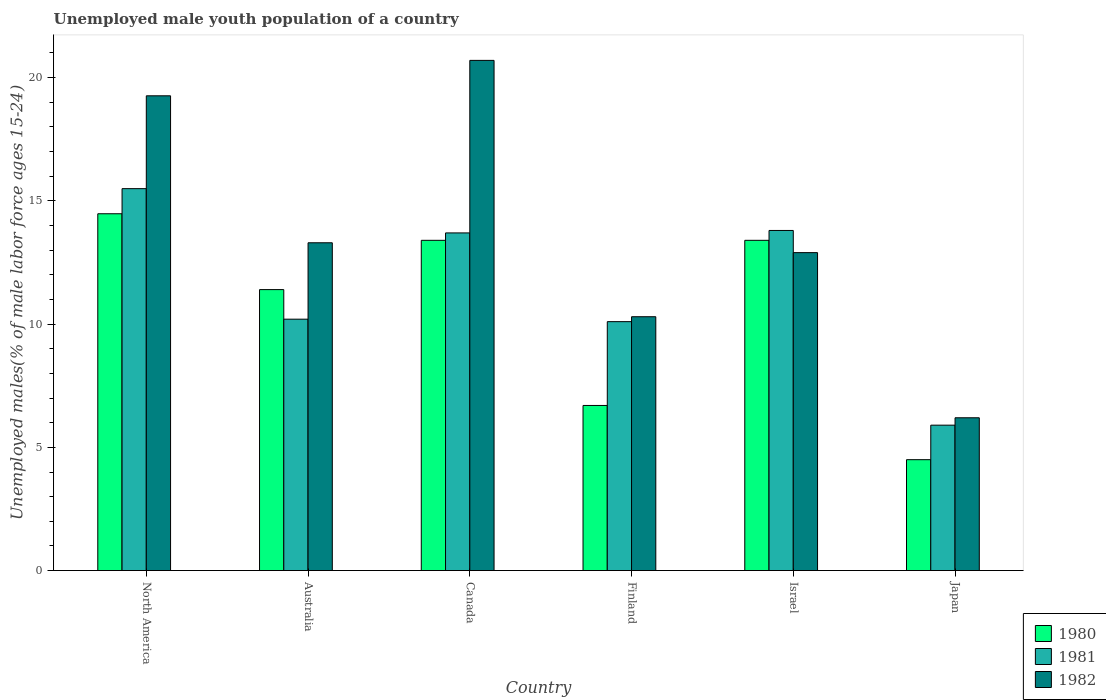How many groups of bars are there?
Your answer should be very brief. 6. What is the label of the 3rd group of bars from the left?
Keep it short and to the point. Canada. In how many cases, is the number of bars for a given country not equal to the number of legend labels?
Make the answer very short. 0. What is the percentage of unemployed male youth population in 1980 in Canada?
Your answer should be compact. 13.4. Across all countries, what is the maximum percentage of unemployed male youth population in 1982?
Provide a succinct answer. 20.7. Across all countries, what is the minimum percentage of unemployed male youth population in 1980?
Offer a very short reply. 4.5. In which country was the percentage of unemployed male youth population in 1982 maximum?
Give a very brief answer. Canada. What is the total percentage of unemployed male youth population in 1981 in the graph?
Give a very brief answer. 69.2. What is the difference between the percentage of unemployed male youth population in 1981 in Australia and that in Canada?
Your response must be concise. -3.5. What is the difference between the percentage of unemployed male youth population in 1982 in Canada and the percentage of unemployed male youth population in 1980 in Australia?
Your answer should be very brief. 9.3. What is the average percentage of unemployed male youth population in 1980 per country?
Your answer should be compact. 10.65. What is the difference between the percentage of unemployed male youth population of/in 1981 and percentage of unemployed male youth population of/in 1982 in Israel?
Your answer should be compact. 0.9. What is the ratio of the percentage of unemployed male youth population in 1982 in Japan to that in North America?
Your answer should be very brief. 0.32. Is the percentage of unemployed male youth population in 1981 in Finland less than that in Japan?
Your answer should be compact. No. What is the difference between the highest and the second highest percentage of unemployed male youth population in 1981?
Keep it short and to the point. -0.1. What is the difference between the highest and the lowest percentage of unemployed male youth population in 1981?
Keep it short and to the point. 9.6. Is the sum of the percentage of unemployed male youth population in 1981 in Australia and Israel greater than the maximum percentage of unemployed male youth population in 1980 across all countries?
Keep it short and to the point. Yes. What does the 3rd bar from the left in Finland represents?
Ensure brevity in your answer.  1982. What does the 2nd bar from the right in Japan represents?
Ensure brevity in your answer.  1981. Is it the case that in every country, the sum of the percentage of unemployed male youth population in 1981 and percentage of unemployed male youth population in 1980 is greater than the percentage of unemployed male youth population in 1982?
Make the answer very short. Yes. How many bars are there?
Provide a succinct answer. 18. Are all the bars in the graph horizontal?
Provide a short and direct response. No. What is the difference between two consecutive major ticks on the Y-axis?
Your answer should be compact. 5. Are the values on the major ticks of Y-axis written in scientific E-notation?
Offer a very short reply. No. Does the graph contain grids?
Ensure brevity in your answer.  No. What is the title of the graph?
Provide a succinct answer. Unemployed male youth population of a country. What is the label or title of the X-axis?
Your response must be concise. Country. What is the label or title of the Y-axis?
Give a very brief answer. Unemployed males(% of male labor force ages 15-24). What is the Unemployed males(% of male labor force ages 15-24) of 1980 in North America?
Offer a very short reply. 14.48. What is the Unemployed males(% of male labor force ages 15-24) in 1981 in North America?
Make the answer very short. 15.5. What is the Unemployed males(% of male labor force ages 15-24) in 1982 in North America?
Ensure brevity in your answer.  19.26. What is the Unemployed males(% of male labor force ages 15-24) of 1980 in Australia?
Offer a terse response. 11.4. What is the Unemployed males(% of male labor force ages 15-24) of 1981 in Australia?
Make the answer very short. 10.2. What is the Unemployed males(% of male labor force ages 15-24) of 1982 in Australia?
Make the answer very short. 13.3. What is the Unemployed males(% of male labor force ages 15-24) in 1980 in Canada?
Your answer should be compact. 13.4. What is the Unemployed males(% of male labor force ages 15-24) in 1981 in Canada?
Your response must be concise. 13.7. What is the Unemployed males(% of male labor force ages 15-24) in 1982 in Canada?
Your answer should be compact. 20.7. What is the Unemployed males(% of male labor force ages 15-24) in 1980 in Finland?
Ensure brevity in your answer.  6.7. What is the Unemployed males(% of male labor force ages 15-24) in 1981 in Finland?
Offer a terse response. 10.1. What is the Unemployed males(% of male labor force ages 15-24) in 1982 in Finland?
Provide a short and direct response. 10.3. What is the Unemployed males(% of male labor force ages 15-24) of 1980 in Israel?
Offer a very short reply. 13.4. What is the Unemployed males(% of male labor force ages 15-24) in 1981 in Israel?
Provide a short and direct response. 13.8. What is the Unemployed males(% of male labor force ages 15-24) in 1982 in Israel?
Provide a short and direct response. 12.9. What is the Unemployed males(% of male labor force ages 15-24) of 1981 in Japan?
Give a very brief answer. 5.9. What is the Unemployed males(% of male labor force ages 15-24) of 1982 in Japan?
Offer a very short reply. 6.2. Across all countries, what is the maximum Unemployed males(% of male labor force ages 15-24) of 1980?
Provide a short and direct response. 14.48. Across all countries, what is the maximum Unemployed males(% of male labor force ages 15-24) of 1981?
Keep it short and to the point. 15.5. Across all countries, what is the maximum Unemployed males(% of male labor force ages 15-24) of 1982?
Provide a short and direct response. 20.7. Across all countries, what is the minimum Unemployed males(% of male labor force ages 15-24) of 1980?
Your answer should be very brief. 4.5. Across all countries, what is the minimum Unemployed males(% of male labor force ages 15-24) of 1981?
Give a very brief answer. 5.9. Across all countries, what is the minimum Unemployed males(% of male labor force ages 15-24) in 1982?
Your answer should be very brief. 6.2. What is the total Unemployed males(% of male labor force ages 15-24) in 1980 in the graph?
Your answer should be compact. 63.88. What is the total Unemployed males(% of male labor force ages 15-24) in 1981 in the graph?
Make the answer very short. 69.2. What is the total Unemployed males(% of male labor force ages 15-24) of 1982 in the graph?
Your answer should be very brief. 82.66. What is the difference between the Unemployed males(% of male labor force ages 15-24) of 1980 in North America and that in Australia?
Ensure brevity in your answer.  3.08. What is the difference between the Unemployed males(% of male labor force ages 15-24) in 1981 in North America and that in Australia?
Provide a succinct answer. 5.3. What is the difference between the Unemployed males(% of male labor force ages 15-24) of 1982 in North America and that in Australia?
Provide a short and direct response. 5.96. What is the difference between the Unemployed males(% of male labor force ages 15-24) of 1980 in North America and that in Canada?
Make the answer very short. 1.08. What is the difference between the Unemployed males(% of male labor force ages 15-24) in 1981 in North America and that in Canada?
Make the answer very short. 1.8. What is the difference between the Unemployed males(% of male labor force ages 15-24) in 1982 in North America and that in Canada?
Make the answer very short. -1.44. What is the difference between the Unemployed males(% of male labor force ages 15-24) in 1980 in North America and that in Finland?
Provide a succinct answer. 7.78. What is the difference between the Unemployed males(% of male labor force ages 15-24) of 1981 in North America and that in Finland?
Your answer should be very brief. 5.4. What is the difference between the Unemployed males(% of male labor force ages 15-24) of 1982 in North America and that in Finland?
Make the answer very short. 8.96. What is the difference between the Unemployed males(% of male labor force ages 15-24) in 1980 in North America and that in Israel?
Your response must be concise. 1.08. What is the difference between the Unemployed males(% of male labor force ages 15-24) in 1981 in North America and that in Israel?
Make the answer very short. 1.7. What is the difference between the Unemployed males(% of male labor force ages 15-24) of 1982 in North America and that in Israel?
Your answer should be compact. 6.36. What is the difference between the Unemployed males(% of male labor force ages 15-24) of 1980 in North America and that in Japan?
Your answer should be compact. 9.98. What is the difference between the Unemployed males(% of male labor force ages 15-24) in 1981 in North America and that in Japan?
Provide a short and direct response. 9.6. What is the difference between the Unemployed males(% of male labor force ages 15-24) of 1982 in North America and that in Japan?
Provide a short and direct response. 13.06. What is the difference between the Unemployed males(% of male labor force ages 15-24) in 1980 in Australia and that in Finland?
Your response must be concise. 4.7. What is the difference between the Unemployed males(% of male labor force ages 15-24) of 1982 in Australia and that in Finland?
Your answer should be very brief. 3. What is the difference between the Unemployed males(% of male labor force ages 15-24) in 1980 in Australia and that in Israel?
Provide a succinct answer. -2. What is the difference between the Unemployed males(% of male labor force ages 15-24) of 1982 in Australia and that in Israel?
Ensure brevity in your answer.  0.4. What is the difference between the Unemployed males(% of male labor force ages 15-24) in 1981 in Australia and that in Japan?
Provide a succinct answer. 4.3. What is the difference between the Unemployed males(% of male labor force ages 15-24) of 1982 in Australia and that in Japan?
Give a very brief answer. 7.1. What is the difference between the Unemployed males(% of male labor force ages 15-24) in 1981 in Canada and that in Finland?
Your answer should be very brief. 3.6. What is the difference between the Unemployed males(% of male labor force ages 15-24) of 1982 in Canada and that in Israel?
Your answer should be very brief. 7.8. What is the difference between the Unemployed males(% of male labor force ages 15-24) of 1980 in Canada and that in Japan?
Ensure brevity in your answer.  8.9. What is the difference between the Unemployed males(% of male labor force ages 15-24) in 1981 in Canada and that in Japan?
Offer a very short reply. 7.8. What is the difference between the Unemployed males(% of male labor force ages 15-24) of 1981 in Finland and that in Israel?
Give a very brief answer. -3.7. What is the difference between the Unemployed males(% of male labor force ages 15-24) in 1982 in Israel and that in Japan?
Offer a very short reply. 6.7. What is the difference between the Unemployed males(% of male labor force ages 15-24) of 1980 in North America and the Unemployed males(% of male labor force ages 15-24) of 1981 in Australia?
Offer a terse response. 4.28. What is the difference between the Unemployed males(% of male labor force ages 15-24) of 1980 in North America and the Unemployed males(% of male labor force ages 15-24) of 1982 in Australia?
Your response must be concise. 1.18. What is the difference between the Unemployed males(% of male labor force ages 15-24) in 1981 in North America and the Unemployed males(% of male labor force ages 15-24) in 1982 in Australia?
Provide a short and direct response. 2.2. What is the difference between the Unemployed males(% of male labor force ages 15-24) of 1980 in North America and the Unemployed males(% of male labor force ages 15-24) of 1981 in Canada?
Your answer should be compact. 0.78. What is the difference between the Unemployed males(% of male labor force ages 15-24) in 1980 in North America and the Unemployed males(% of male labor force ages 15-24) in 1982 in Canada?
Your response must be concise. -6.22. What is the difference between the Unemployed males(% of male labor force ages 15-24) in 1981 in North America and the Unemployed males(% of male labor force ages 15-24) in 1982 in Canada?
Keep it short and to the point. -5.2. What is the difference between the Unemployed males(% of male labor force ages 15-24) in 1980 in North America and the Unemployed males(% of male labor force ages 15-24) in 1981 in Finland?
Keep it short and to the point. 4.38. What is the difference between the Unemployed males(% of male labor force ages 15-24) of 1980 in North America and the Unemployed males(% of male labor force ages 15-24) of 1982 in Finland?
Offer a very short reply. 4.18. What is the difference between the Unemployed males(% of male labor force ages 15-24) of 1981 in North America and the Unemployed males(% of male labor force ages 15-24) of 1982 in Finland?
Offer a very short reply. 5.2. What is the difference between the Unemployed males(% of male labor force ages 15-24) in 1980 in North America and the Unemployed males(% of male labor force ages 15-24) in 1981 in Israel?
Provide a short and direct response. 0.68. What is the difference between the Unemployed males(% of male labor force ages 15-24) in 1980 in North America and the Unemployed males(% of male labor force ages 15-24) in 1982 in Israel?
Provide a succinct answer. 1.58. What is the difference between the Unemployed males(% of male labor force ages 15-24) of 1981 in North America and the Unemployed males(% of male labor force ages 15-24) of 1982 in Israel?
Offer a terse response. 2.6. What is the difference between the Unemployed males(% of male labor force ages 15-24) in 1980 in North America and the Unemployed males(% of male labor force ages 15-24) in 1981 in Japan?
Your response must be concise. 8.58. What is the difference between the Unemployed males(% of male labor force ages 15-24) in 1980 in North America and the Unemployed males(% of male labor force ages 15-24) in 1982 in Japan?
Ensure brevity in your answer.  8.28. What is the difference between the Unemployed males(% of male labor force ages 15-24) in 1981 in North America and the Unemployed males(% of male labor force ages 15-24) in 1982 in Japan?
Your response must be concise. 9.3. What is the difference between the Unemployed males(% of male labor force ages 15-24) in 1980 in Australia and the Unemployed males(% of male labor force ages 15-24) in 1982 in Canada?
Provide a succinct answer. -9.3. What is the difference between the Unemployed males(% of male labor force ages 15-24) in 1981 in Australia and the Unemployed males(% of male labor force ages 15-24) in 1982 in Canada?
Your answer should be compact. -10.5. What is the difference between the Unemployed males(% of male labor force ages 15-24) of 1980 in Australia and the Unemployed males(% of male labor force ages 15-24) of 1982 in Finland?
Ensure brevity in your answer.  1.1. What is the difference between the Unemployed males(% of male labor force ages 15-24) of 1980 in Australia and the Unemployed males(% of male labor force ages 15-24) of 1981 in Israel?
Offer a terse response. -2.4. What is the difference between the Unemployed males(% of male labor force ages 15-24) in 1981 in Australia and the Unemployed males(% of male labor force ages 15-24) in 1982 in Israel?
Your answer should be compact. -2.7. What is the difference between the Unemployed males(% of male labor force ages 15-24) in 1980 in Australia and the Unemployed males(% of male labor force ages 15-24) in 1981 in Japan?
Provide a short and direct response. 5.5. What is the difference between the Unemployed males(% of male labor force ages 15-24) in 1980 in Australia and the Unemployed males(% of male labor force ages 15-24) in 1982 in Japan?
Your response must be concise. 5.2. What is the difference between the Unemployed males(% of male labor force ages 15-24) in 1981 in Australia and the Unemployed males(% of male labor force ages 15-24) in 1982 in Japan?
Offer a terse response. 4. What is the difference between the Unemployed males(% of male labor force ages 15-24) of 1980 in Canada and the Unemployed males(% of male labor force ages 15-24) of 1982 in Finland?
Your response must be concise. 3.1. What is the difference between the Unemployed males(% of male labor force ages 15-24) of 1980 in Canada and the Unemployed males(% of male labor force ages 15-24) of 1981 in Israel?
Offer a terse response. -0.4. What is the difference between the Unemployed males(% of male labor force ages 15-24) in 1980 in Canada and the Unemployed males(% of male labor force ages 15-24) in 1982 in Israel?
Make the answer very short. 0.5. What is the difference between the Unemployed males(% of male labor force ages 15-24) of 1980 in Canada and the Unemployed males(% of male labor force ages 15-24) of 1982 in Japan?
Offer a very short reply. 7.2. What is the difference between the Unemployed males(% of male labor force ages 15-24) in 1980 in Finland and the Unemployed males(% of male labor force ages 15-24) in 1981 in Israel?
Provide a short and direct response. -7.1. What is the difference between the Unemployed males(% of male labor force ages 15-24) in 1981 in Finland and the Unemployed males(% of male labor force ages 15-24) in 1982 in Israel?
Your response must be concise. -2.8. What is the difference between the Unemployed males(% of male labor force ages 15-24) in 1981 in Finland and the Unemployed males(% of male labor force ages 15-24) in 1982 in Japan?
Offer a terse response. 3.9. What is the average Unemployed males(% of male labor force ages 15-24) of 1980 per country?
Keep it short and to the point. 10.65. What is the average Unemployed males(% of male labor force ages 15-24) of 1981 per country?
Offer a terse response. 11.53. What is the average Unemployed males(% of male labor force ages 15-24) of 1982 per country?
Your answer should be compact. 13.78. What is the difference between the Unemployed males(% of male labor force ages 15-24) of 1980 and Unemployed males(% of male labor force ages 15-24) of 1981 in North America?
Your response must be concise. -1.02. What is the difference between the Unemployed males(% of male labor force ages 15-24) of 1980 and Unemployed males(% of male labor force ages 15-24) of 1982 in North America?
Provide a succinct answer. -4.79. What is the difference between the Unemployed males(% of male labor force ages 15-24) of 1981 and Unemployed males(% of male labor force ages 15-24) of 1982 in North America?
Your answer should be very brief. -3.77. What is the difference between the Unemployed males(% of male labor force ages 15-24) in 1980 and Unemployed males(% of male labor force ages 15-24) in 1981 in Australia?
Provide a succinct answer. 1.2. What is the difference between the Unemployed males(% of male labor force ages 15-24) in 1980 and Unemployed males(% of male labor force ages 15-24) in 1982 in Australia?
Make the answer very short. -1.9. What is the difference between the Unemployed males(% of male labor force ages 15-24) in 1981 and Unemployed males(% of male labor force ages 15-24) in 1982 in Australia?
Give a very brief answer. -3.1. What is the difference between the Unemployed males(% of male labor force ages 15-24) of 1980 and Unemployed males(% of male labor force ages 15-24) of 1981 in Finland?
Make the answer very short. -3.4. What is the difference between the Unemployed males(% of male labor force ages 15-24) of 1980 and Unemployed males(% of male labor force ages 15-24) of 1981 in Japan?
Your answer should be very brief. -1.4. What is the difference between the Unemployed males(% of male labor force ages 15-24) of 1980 and Unemployed males(% of male labor force ages 15-24) of 1982 in Japan?
Provide a succinct answer. -1.7. What is the ratio of the Unemployed males(% of male labor force ages 15-24) in 1980 in North America to that in Australia?
Your answer should be very brief. 1.27. What is the ratio of the Unemployed males(% of male labor force ages 15-24) in 1981 in North America to that in Australia?
Give a very brief answer. 1.52. What is the ratio of the Unemployed males(% of male labor force ages 15-24) of 1982 in North America to that in Australia?
Make the answer very short. 1.45. What is the ratio of the Unemployed males(% of male labor force ages 15-24) in 1980 in North America to that in Canada?
Keep it short and to the point. 1.08. What is the ratio of the Unemployed males(% of male labor force ages 15-24) in 1981 in North America to that in Canada?
Offer a very short reply. 1.13. What is the ratio of the Unemployed males(% of male labor force ages 15-24) of 1982 in North America to that in Canada?
Your answer should be compact. 0.93. What is the ratio of the Unemployed males(% of male labor force ages 15-24) of 1980 in North America to that in Finland?
Your response must be concise. 2.16. What is the ratio of the Unemployed males(% of male labor force ages 15-24) in 1981 in North America to that in Finland?
Give a very brief answer. 1.53. What is the ratio of the Unemployed males(% of male labor force ages 15-24) of 1982 in North America to that in Finland?
Offer a very short reply. 1.87. What is the ratio of the Unemployed males(% of male labor force ages 15-24) of 1980 in North America to that in Israel?
Provide a succinct answer. 1.08. What is the ratio of the Unemployed males(% of male labor force ages 15-24) in 1981 in North America to that in Israel?
Provide a short and direct response. 1.12. What is the ratio of the Unemployed males(% of male labor force ages 15-24) of 1982 in North America to that in Israel?
Offer a terse response. 1.49. What is the ratio of the Unemployed males(% of male labor force ages 15-24) of 1980 in North America to that in Japan?
Keep it short and to the point. 3.22. What is the ratio of the Unemployed males(% of male labor force ages 15-24) of 1981 in North America to that in Japan?
Provide a succinct answer. 2.63. What is the ratio of the Unemployed males(% of male labor force ages 15-24) of 1982 in North America to that in Japan?
Provide a short and direct response. 3.11. What is the ratio of the Unemployed males(% of male labor force ages 15-24) of 1980 in Australia to that in Canada?
Your response must be concise. 0.85. What is the ratio of the Unemployed males(% of male labor force ages 15-24) of 1981 in Australia to that in Canada?
Give a very brief answer. 0.74. What is the ratio of the Unemployed males(% of male labor force ages 15-24) in 1982 in Australia to that in Canada?
Provide a short and direct response. 0.64. What is the ratio of the Unemployed males(% of male labor force ages 15-24) of 1980 in Australia to that in Finland?
Provide a succinct answer. 1.7. What is the ratio of the Unemployed males(% of male labor force ages 15-24) in 1981 in Australia to that in Finland?
Keep it short and to the point. 1.01. What is the ratio of the Unemployed males(% of male labor force ages 15-24) in 1982 in Australia to that in Finland?
Offer a very short reply. 1.29. What is the ratio of the Unemployed males(% of male labor force ages 15-24) in 1980 in Australia to that in Israel?
Give a very brief answer. 0.85. What is the ratio of the Unemployed males(% of male labor force ages 15-24) in 1981 in Australia to that in Israel?
Give a very brief answer. 0.74. What is the ratio of the Unemployed males(% of male labor force ages 15-24) of 1982 in Australia to that in Israel?
Offer a very short reply. 1.03. What is the ratio of the Unemployed males(% of male labor force ages 15-24) of 1980 in Australia to that in Japan?
Offer a terse response. 2.53. What is the ratio of the Unemployed males(% of male labor force ages 15-24) of 1981 in Australia to that in Japan?
Provide a short and direct response. 1.73. What is the ratio of the Unemployed males(% of male labor force ages 15-24) in 1982 in Australia to that in Japan?
Your answer should be very brief. 2.15. What is the ratio of the Unemployed males(% of male labor force ages 15-24) of 1981 in Canada to that in Finland?
Provide a short and direct response. 1.36. What is the ratio of the Unemployed males(% of male labor force ages 15-24) of 1982 in Canada to that in Finland?
Keep it short and to the point. 2.01. What is the ratio of the Unemployed males(% of male labor force ages 15-24) of 1980 in Canada to that in Israel?
Make the answer very short. 1. What is the ratio of the Unemployed males(% of male labor force ages 15-24) in 1982 in Canada to that in Israel?
Provide a short and direct response. 1.6. What is the ratio of the Unemployed males(% of male labor force ages 15-24) in 1980 in Canada to that in Japan?
Offer a terse response. 2.98. What is the ratio of the Unemployed males(% of male labor force ages 15-24) of 1981 in Canada to that in Japan?
Make the answer very short. 2.32. What is the ratio of the Unemployed males(% of male labor force ages 15-24) in 1982 in Canada to that in Japan?
Offer a very short reply. 3.34. What is the ratio of the Unemployed males(% of male labor force ages 15-24) of 1981 in Finland to that in Israel?
Ensure brevity in your answer.  0.73. What is the ratio of the Unemployed males(% of male labor force ages 15-24) in 1982 in Finland to that in Israel?
Keep it short and to the point. 0.8. What is the ratio of the Unemployed males(% of male labor force ages 15-24) in 1980 in Finland to that in Japan?
Your response must be concise. 1.49. What is the ratio of the Unemployed males(% of male labor force ages 15-24) of 1981 in Finland to that in Japan?
Your response must be concise. 1.71. What is the ratio of the Unemployed males(% of male labor force ages 15-24) in 1982 in Finland to that in Japan?
Your answer should be compact. 1.66. What is the ratio of the Unemployed males(% of male labor force ages 15-24) in 1980 in Israel to that in Japan?
Give a very brief answer. 2.98. What is the ratio of the Unemployed males(% of male labor force ages 15-24) of 1981 in Israel to that in Japan?
Offer a terse response. 2.34. What is the ratio of the Unemployed males(% of male labor force ages 15-24) in 1982 in Israel to that in Japan?
Your answer should be compact. 2.08. What is the difference between the highest and the second highest Unemployed males(% of male labor force ages 15-24) of 1980?
Provide a short and direct response. 1.08. What is the difference between the highest and the second highest Unemployed males(% of male labor force ages 15-24) of 1981?
Ensure brevity in your answer.  1.7. What is the difference between the highest and the second highest Unemployed males(% of male labor force ages 15-24) in 1982?
Your answer should be compact. 1.44. What is the difference between the highest and the lowest Unemployed males(% of male labor force ages 15-24) of 1980?
Your answer should be compact. 9.98. What is the difference between the highest and the lowest Unemployed males(% of male labor force ages 15-24) of 1981?
Offer a very short reply. 9.6. 